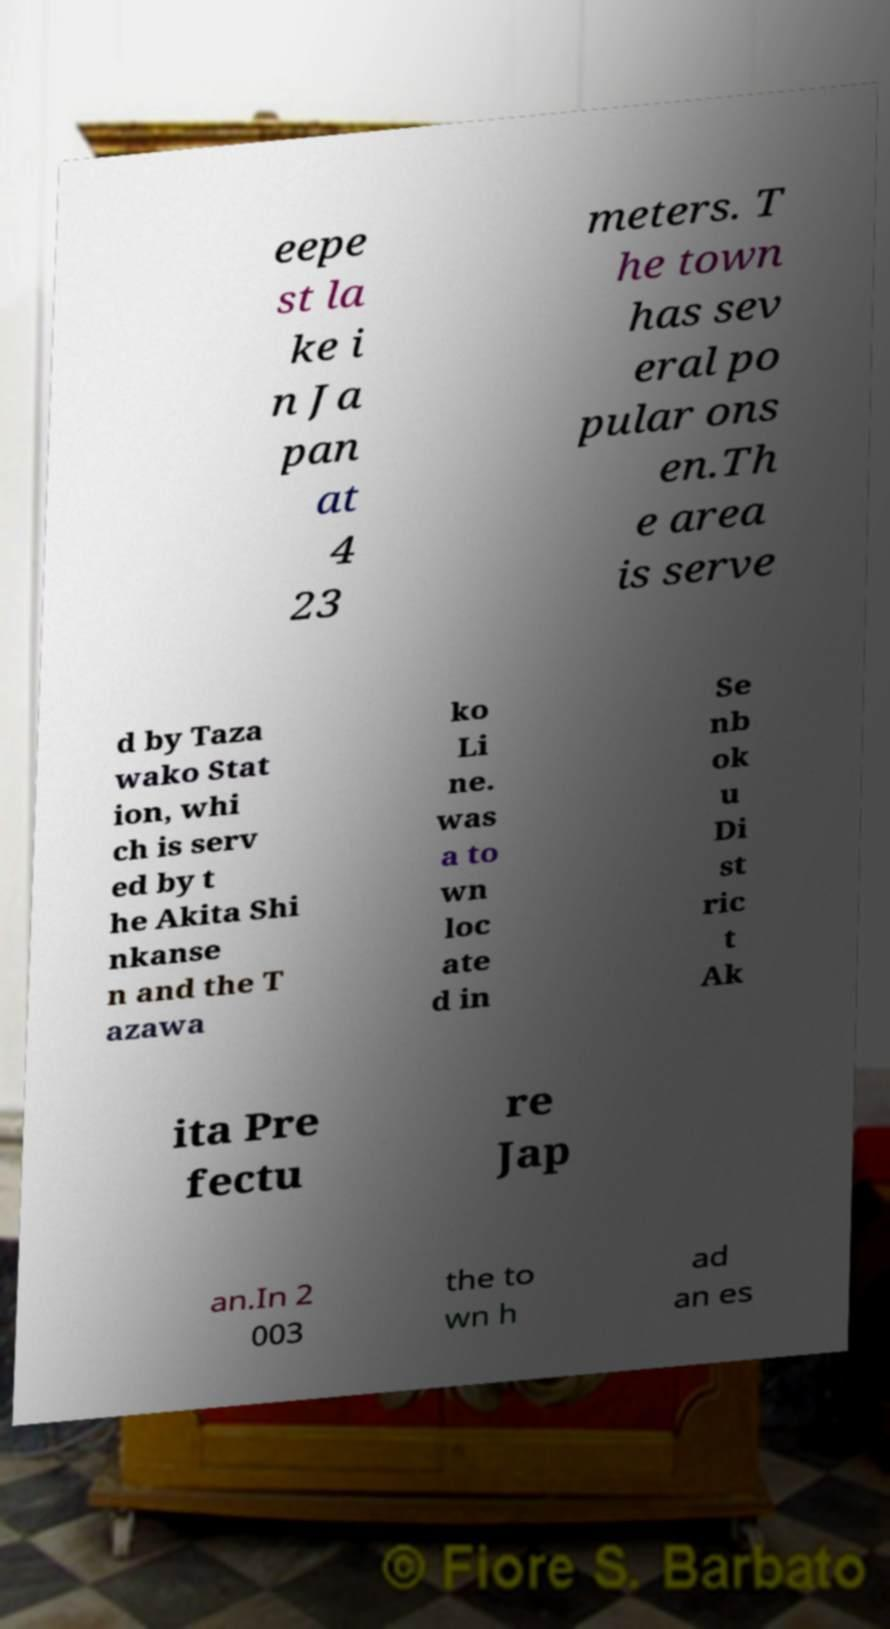Can you accurately transcribe the text from the provided image for me? eepe st la ke i n Ja pan at 4 23 meters. T he town has sev eral po pular ons en.Th e area is serve d by Taza wako Stat ion, whi ch is serv ed by t he Akita Shi nkanse n and the T azawa ko Li ne. was a to wn loc ate d in Se nb ok u Di st ric t Ak ita Pre fectu re Jap an.In 2 003 the to wn h ad an es 